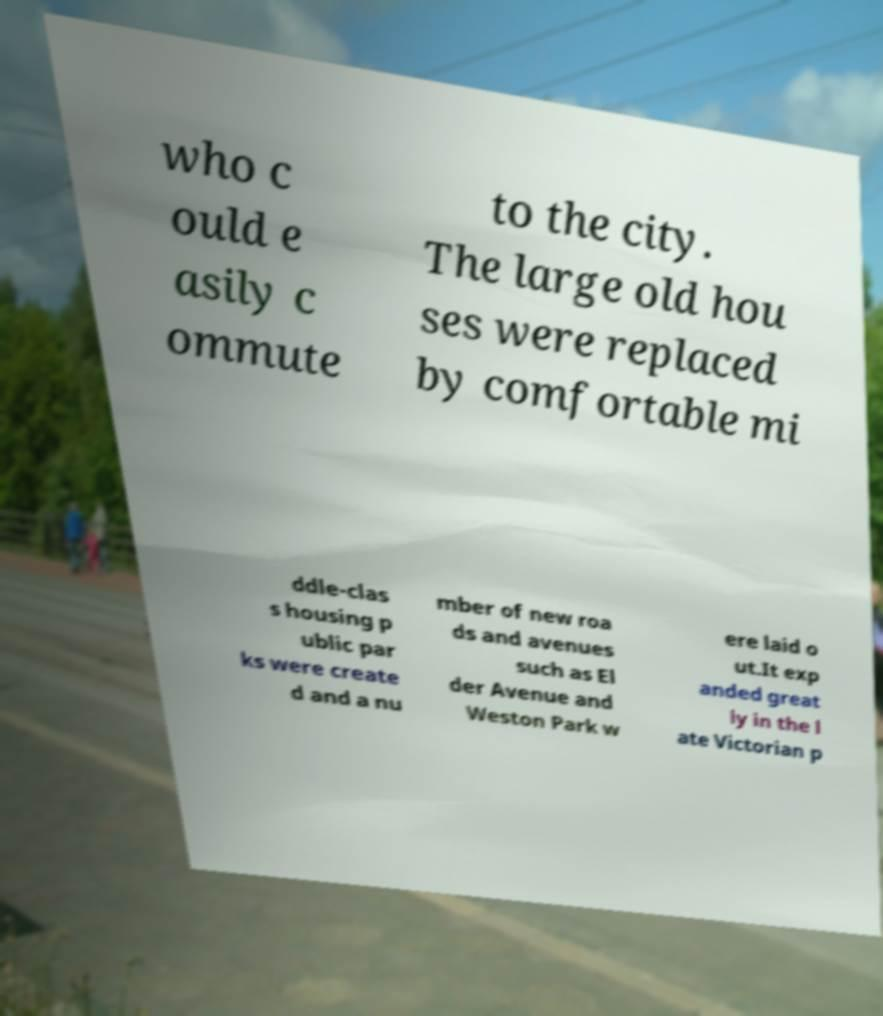There's text embedded in this image that I need extracted. Can you transcribe it verbatim? who c ould e asily c ommute to the city. The large old hou ses were replaced by comfortable mi ddle-clas s housing p ublic par ks were create d and a nu mber of new roa ds and avenues such as El der Avenue and Weston Park w ere laid o ut.It exp anded great ly in the l ate Victorian p 